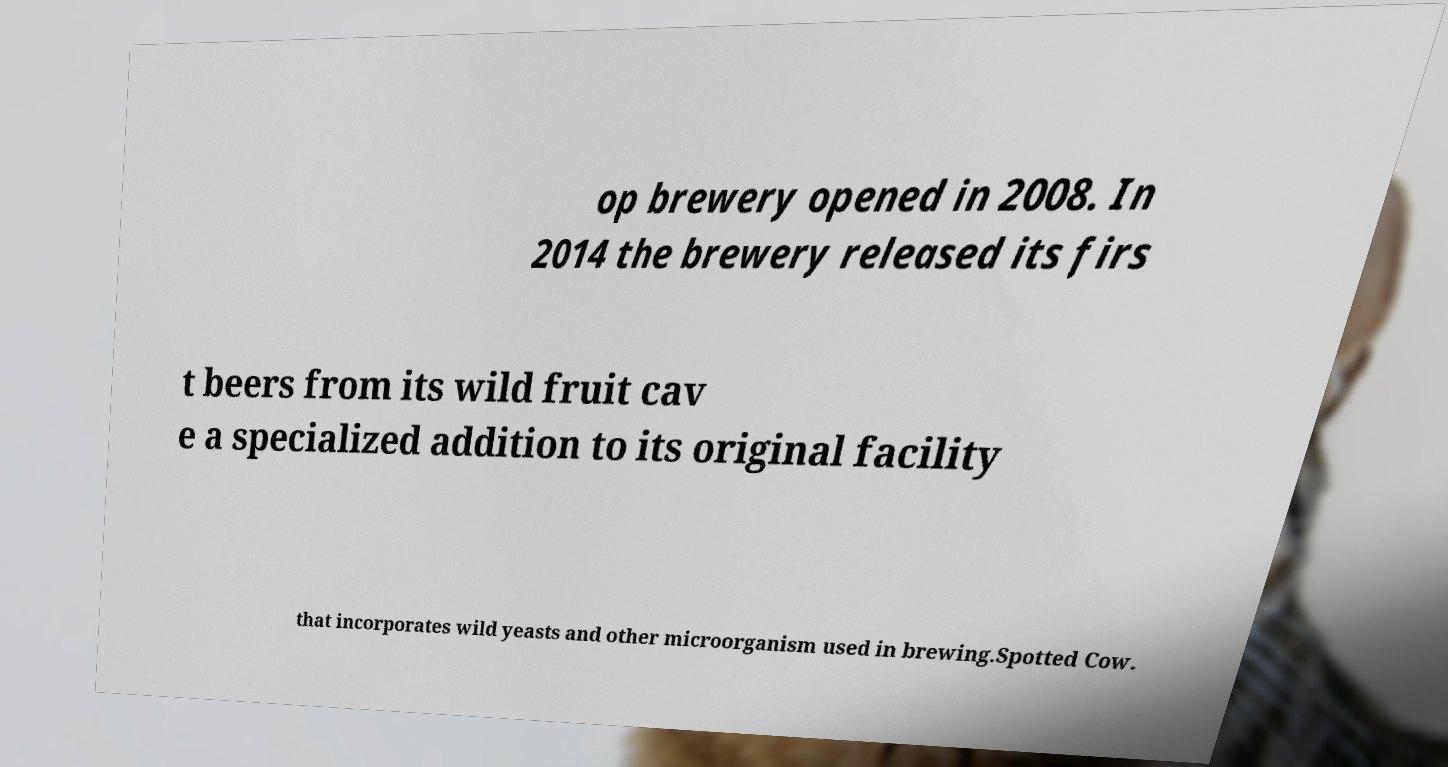Please read and relay the text visible in this image. What does it say? op brewery opened in 2008. In 2014 the brewery released its firs t beers from its wild fruit cav e a specialized addition to its original facility that incorporates wild yeasts and other microorganism used in brewing.Spotted Cow. 